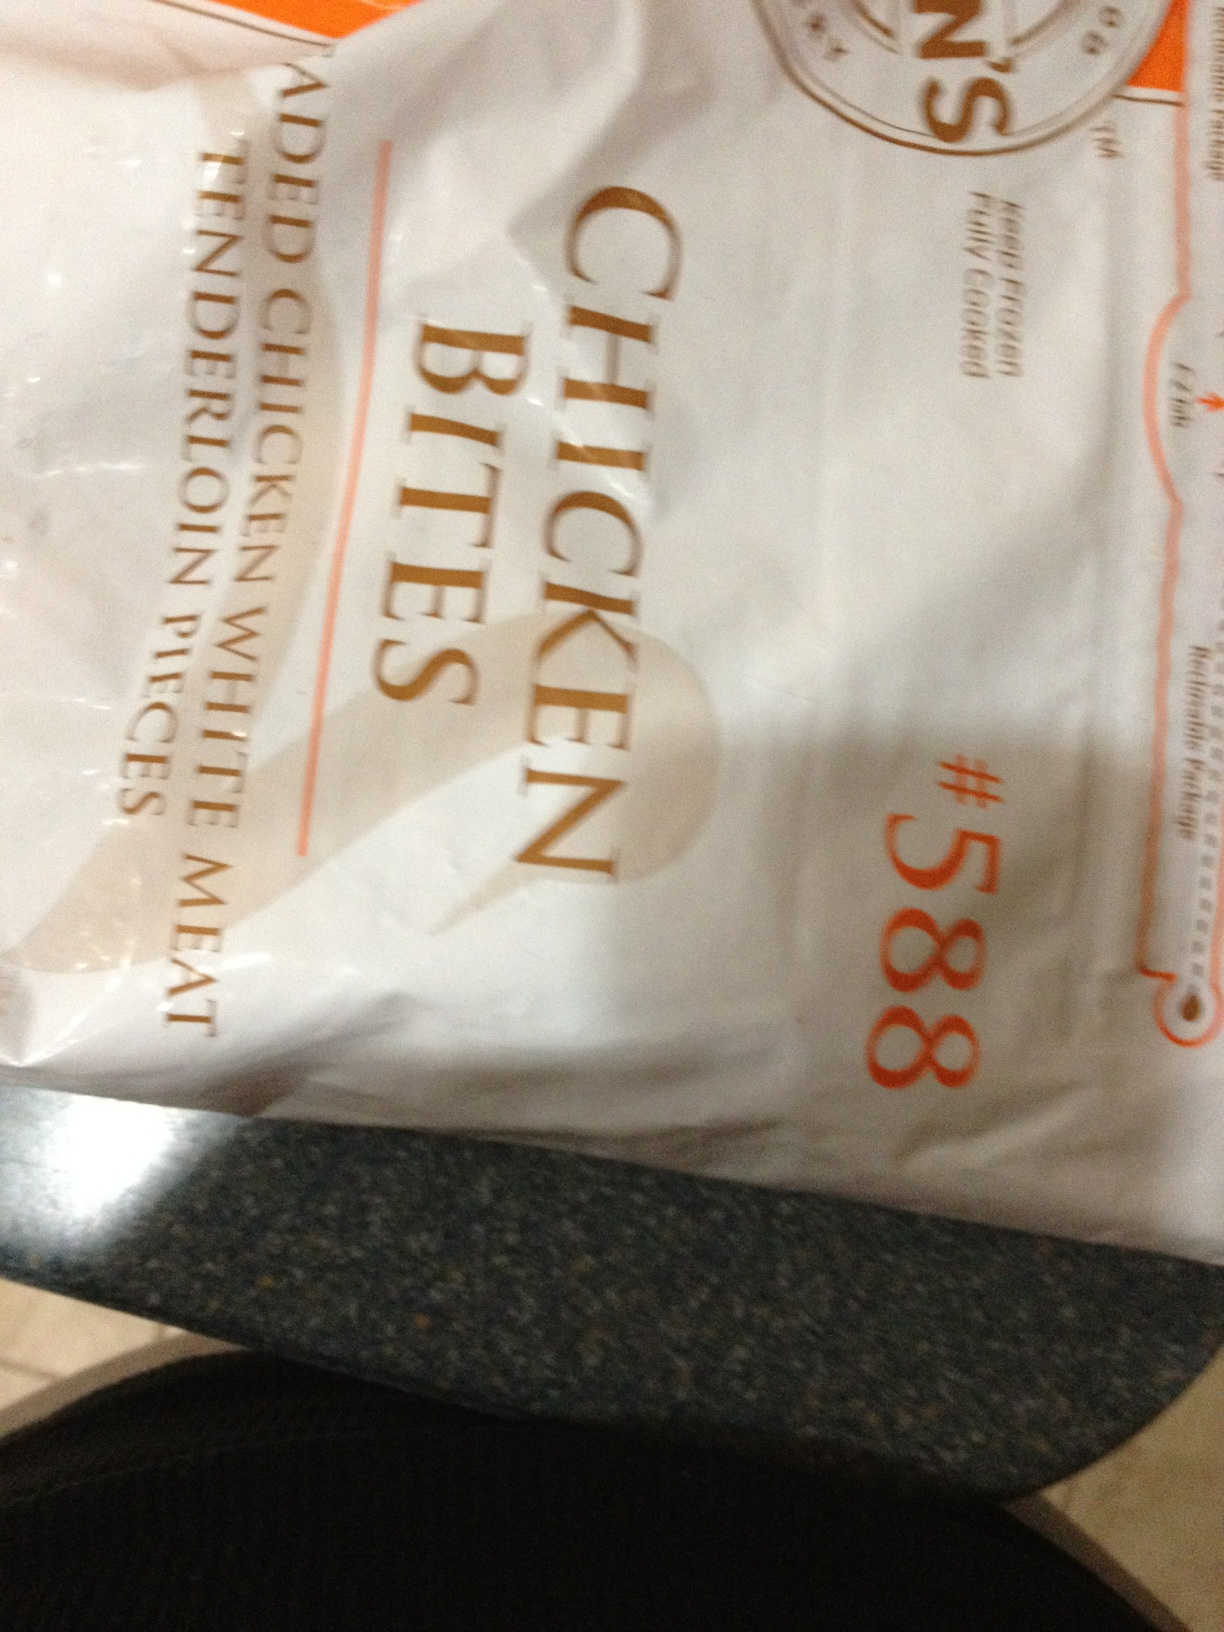Can you explain what 'added chicken tenderloin with rice meat' means as seen on this package? The label 'added chicken tenderloin with rice meat' suggests that the product contains chicken tenderloin that has been enhanced or combined with additional ingredients, possibly including rice meat which usually implies rice-based fillers or extenders. This combination can be used to improve texture or add bulk to the chicken bites. 